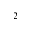<formula> <loc_0><loc_0><loc_500><loc_500>^ { 2 }</formula> 